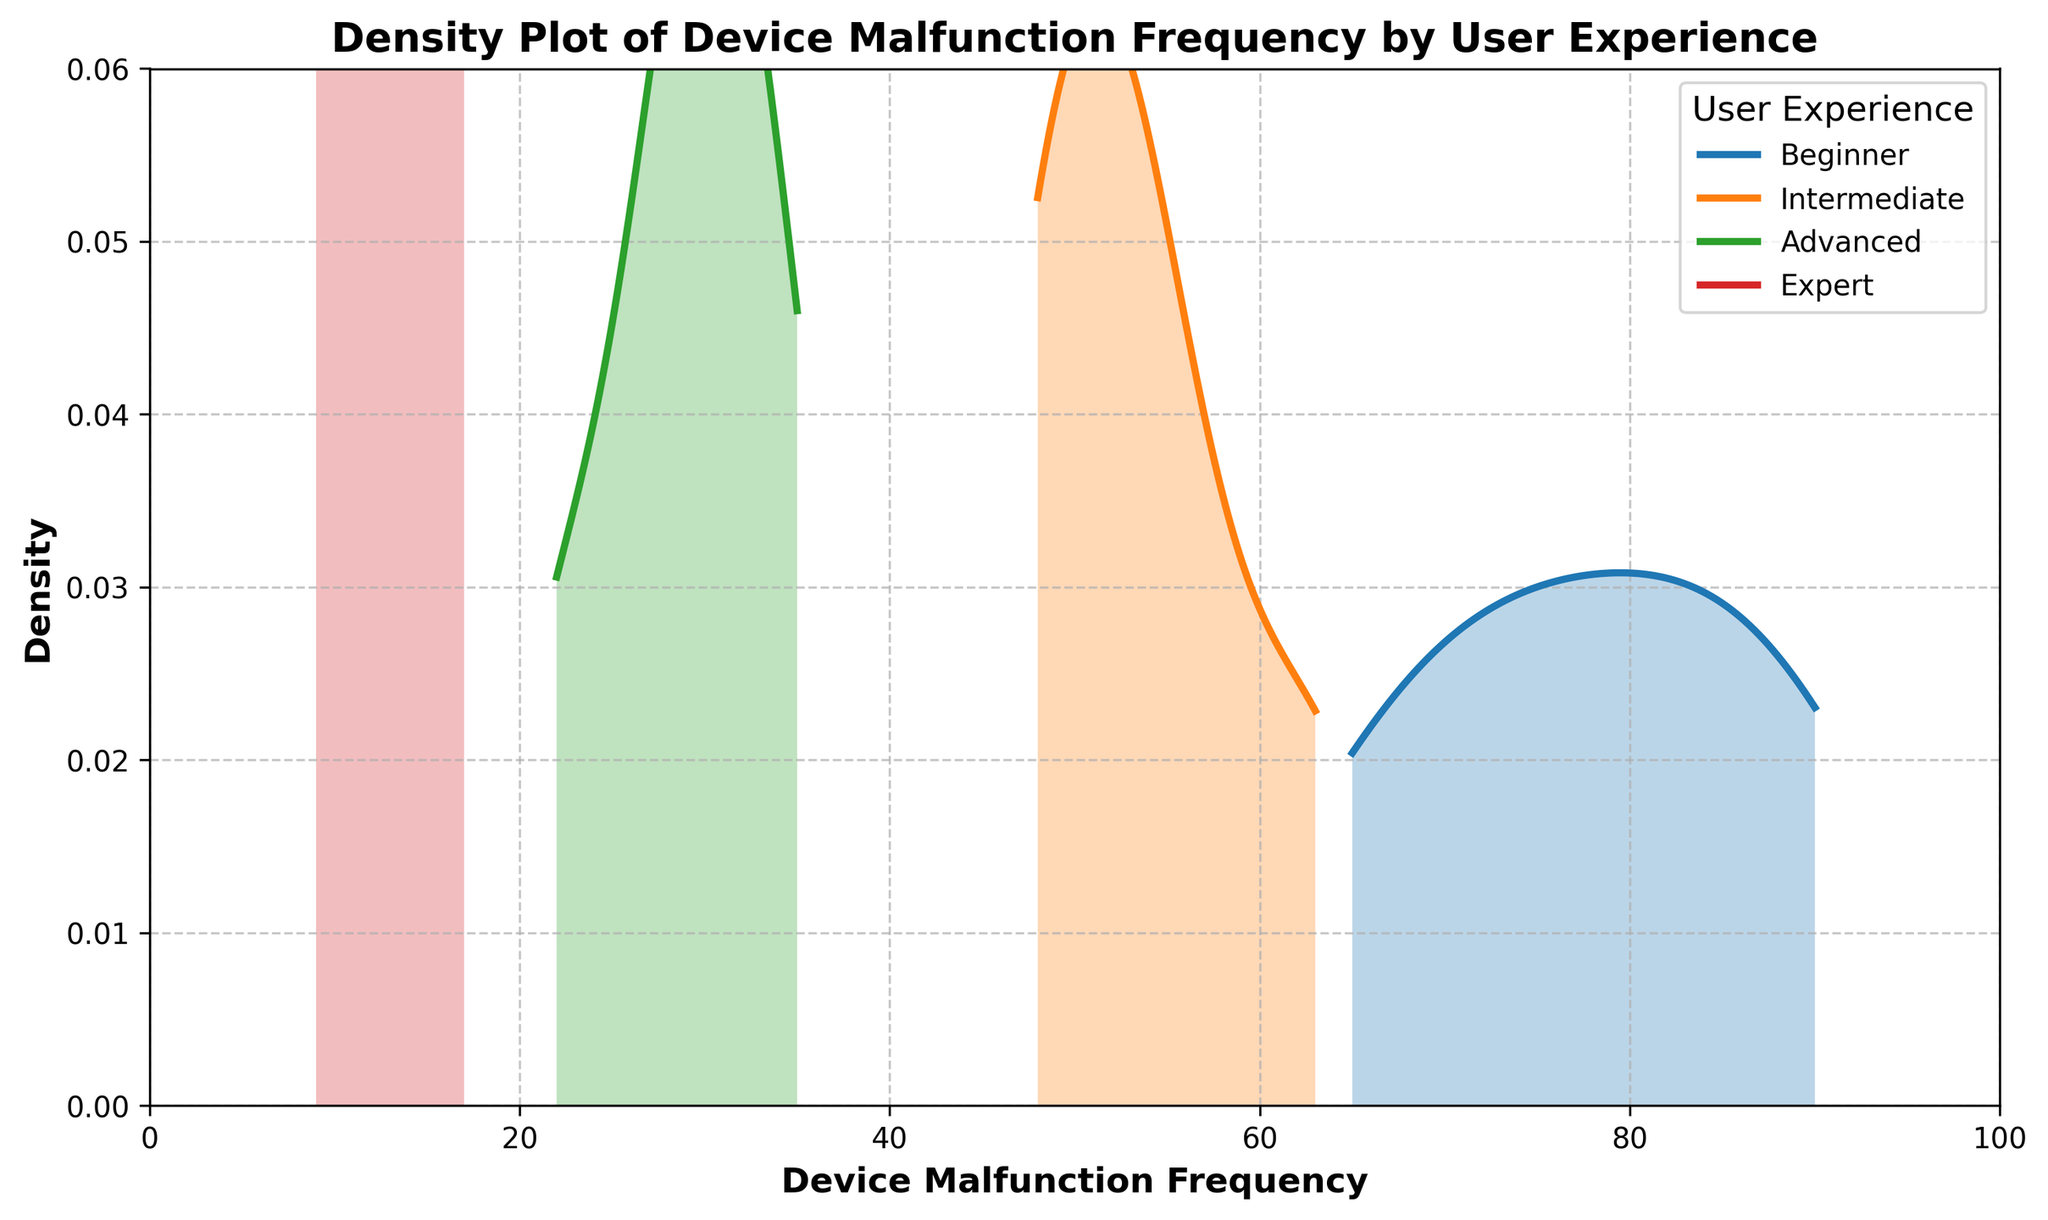What user experience level shows the highest peak in density? By looking at the density plot, identify the curve with the highest peak. This will correspond to the user experience level with the most frequent device malfunctions. The peak density for beginners is the highest.
Answer: Beginners Which user experience level has the lowest density peak? Identify the curve with the lowest peak in the density plot. This involves visual comparison of the heights of each curve. Experts have the lowest density peak.
Answer: Experts At approximately what value of device malfunction frequency do beginners show a peak in density? Look at the x-axis for the beginners' density plot to find the x-value at which the curve reaches its maximum height. The beginners' peak occurs around a malfunction frequency of 80.
Answer: 80 Which user experience group has the most spread-out distribution of malfunction frequencies? Observe the width of the density plots for each user experience group. The group with the widest distribution curve has the most spread-out frequencies. Beginners have the most spread-out distribution.
Answer: Beginners How does the density peak of advanced users compare to intermediate users? Compare the height and position of the density peaks of advanced and intermediate users. The density peak of advanced users is lower and occurs at lower frequencies compared to intermediate users.
Answer: Lower and at lower frequencies What can you infer about the device malfunction frequencies of experts compared to other groups? Check the position and height of the experts' density curve relative to others. The experts' curve is positioned at the lowest frequencies and has the lowest peak, indicating fewer and less frequent malfunctions.
Answer: Low frequencies and fewer malfunctions What does the density plot suggest about the relationship between user experience and device malfunctions? Analyze the overall trend in the density curves as user experience increases. Densities generally show that higher user experience levels correspond to lower device malfunction frequencies.
Answer: Inversely related Between which two user experience levels is the difference in peak densities the smallest? Compare the peak heights of all adjacent user experience levels and identify the two levels with the smallest difference. The smallest difference in peak density is between intermediate and advanced users.
Answer: Intermediate and advanced Which user experience group has a peak density at around 50 malfunction frequency? Locate the area about 50 on the x-axis and determine which group's peak is closest to this value. Intermediate users have a peak density around 50 malfunction frequency.
Answer: Intermediate users What is the range of device malfunction frequencies for the experts' density plot? Identify the minimum and maximum x-values for the experts' density curve. Experts have a range from approximately 9 to 17.
Answer: 9 to 17 